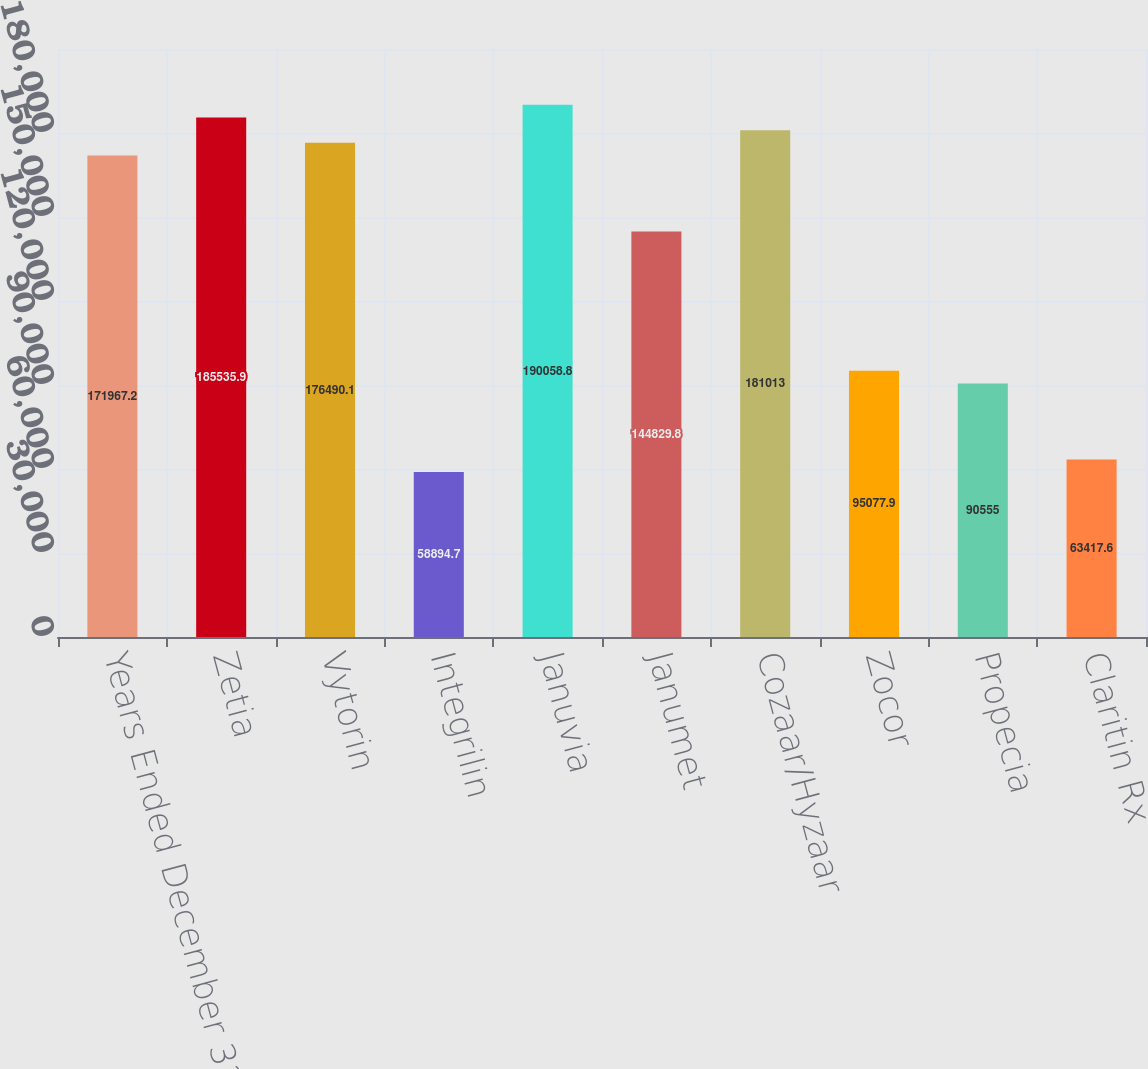Convert chart to OTSL. <chart><loc_0><loc_0><loc_500><loc_500><bar_chart><fcel>Years Ended December 31<fcel>Zetia<fcel>Vytorin<fcel>Integrilin<fcel>Januvia<fcel>Janumet<fcel>Cozaar/Hyzaar<fcel>Zocor<fcel>Propecia<fcel>Claritin Rx<nl><fcel>171967<fcel>185536<fcel>176490<fcel>58894.7<fcel>190059<fcel>144830<fcel>181013<fcel>95077.9<fcel>90555<fcel>63417.6<nl></chart> 